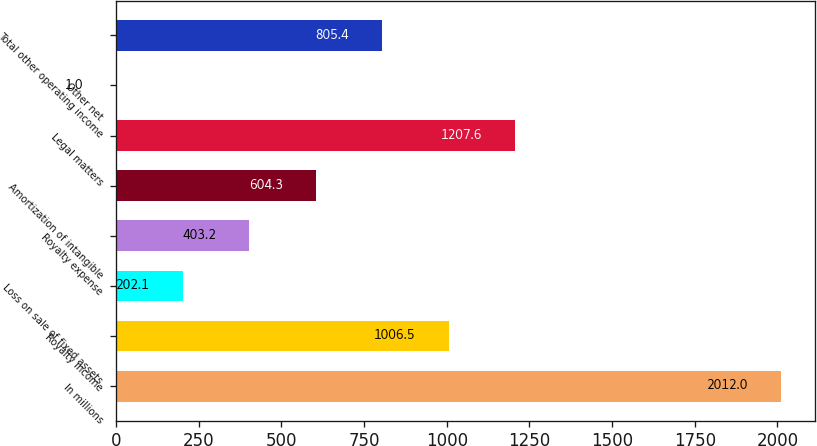Convert chart. <chart><loc_0><loc_0><loc_500><loc_500><bar_chart><fcel>In millions<fcel>Royalty income<fcel>Loss on sale of fixed assets<fcel>Royalty expense<fcel>Amortization of intangible<fcel>Legal matters<fcel>Other net<fcel>Total other operating income<nl><fcel>2012<fcel>1006.5<fcel>202.1<fcel>403.2<fcel>604.3<fcel>1207.6<fcel>1<fcel>805.4<nl></chart> 